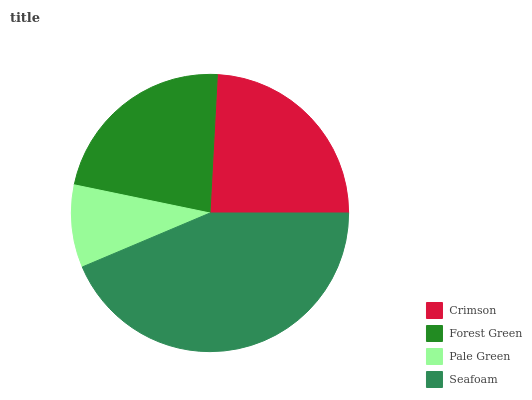Is Pale Green the minimum?
Answer yes or no. Yes. Is Seafoam the maximum?
Answer yes or no. Yes. Is Forest Green the minimum?
Answer yes or no. No. Is Forest Green the maximum?
Answer yes or no. No. Is Crimson greater than Forest Green?
Answer yes or no. Yes. Is Forest Green less than Crimson?
Answer yes or no. Yes. Is Forest Green greater than Crimson?
Answer yes or no. No. Is Crimson less than Forest Green?
Answer yes or no. No. Is Crimson the high median?
Answer yes or no. Yes. Is Forest Green the low median?
Answer yes or no. Yes. Is Seafoam the high median?
Answer yes or no. No. Is Crimson the low median?
Answer yes or no. No. 